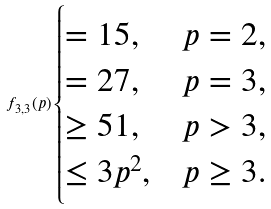Convert formula to latex. <formula><loc_0><loc_0><loc_500><loc_500>f _ { 3 , 3 } ( p ) \begin{cases} = 1 5 , & p = 2 , \\ = 2 7 , & p = 3 , \\ \geq 5 1 , & p > 3 , \\ \leq 3 p ^ { 2 } , & p \geq 3 . \end{cases}</formula> 